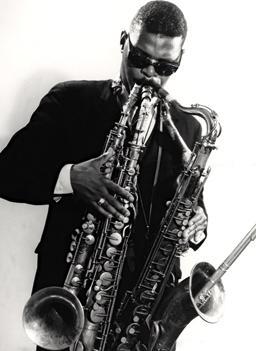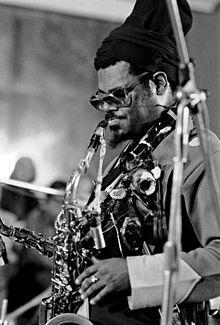The first image is the image on the left, the second image is the image on the right. Considering the images on both sides, is "An image shows a sax player wearing a tall black hat and glasses." valid? Answer yes or no. Yes. The first image is the image on the left, the second image is the image on the right. Analyze the images presented: Is the assertion "There are three or more people clearly visible." valid? Answer yes or no. No. 